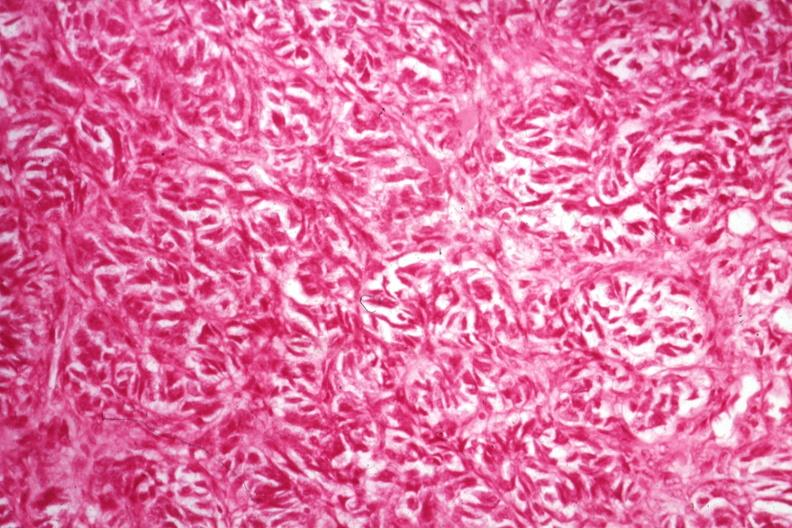s hilar cell tumor present?
Answer the question using a single word or phrase. Yes 